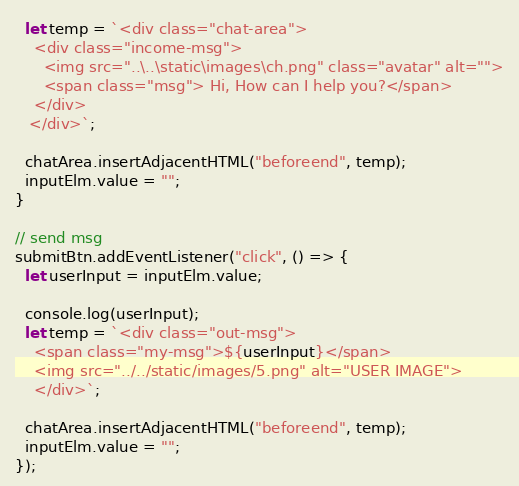Convert code to text. <code><loc_0><loc_0><loc_500><loc_500><_JavaScript_>  let temp = `<div class="chat-area">
    <div class="income-msg">
      <img src="..\..\static\images\ch.png" class="avatar" alt="">
      <span class="msg"> Hi, How can I help you?</span>
    </div>   
   </div>`;

  chatArea.insertAdjacentHTML("beforeend", temp);
  inputElm.value = "";
}

// send msg
submitBtn.addEventListener("click", () => {
  let userInput = inputElm.value;

  console.log(userInput);
  let temp = `<div class="out-msg">
    <span class="my-msg">${userInput}</span>
    <img src="../../static/images/5.png" alt="USER IMAGE">
    </div>`;

  chatArea.insertAdjacentHTML("beforeend", temp);
  inputElm.value = "";
});
</code> 